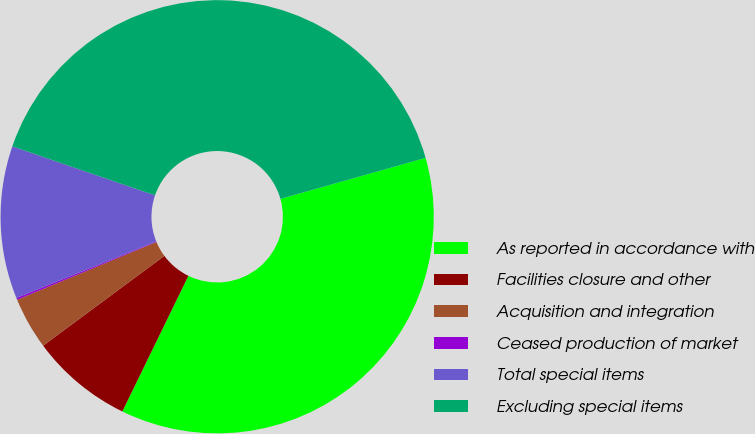Convert chart. <chart><loc_0><loc_0><loc_500><loc_500><pie_chart><fcel>As reported in accordance with<fcel>Facilities closure and other<fcel>Acquisition and integration<fcel>Ceased production of market<fcel>Total special items<fcel>Excluding special items<nl><fcel>36.6%<fcel>7.64%<fcel>3.89%<fcel>0.14%<fcel>11.39%<fcel>40.35%<nl></chart> 